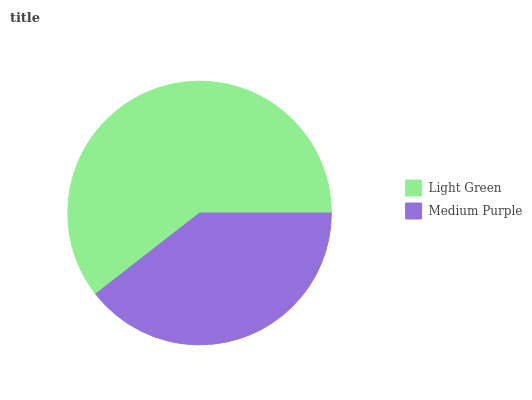Is Medium Purple the minimum?
Answer yes or no. Yes. Is Light Green the maximum?
Answer yes or no. Yes. Is Medium Purple the maximum?
Answer yes or no. No. Is Light Green greater than Medium Purple?
Answer yes or no. Yes. Is Medium Purple less than Light Green?
Answer yes or no. Yes. Is Medium Purple greater than Light Green?
Answer yes or no. No. Is Light Green less than Medium Purple?
Answer yes or no. No. Is Light Green the high median?
Answer yes or no. Yes. Is Medium Purple the low median?
Answer yes or no. Yes. Is Medium Purple the high median?
Answer yes or no. No. Is Light Green the low median?
Answer yes or no. No. 